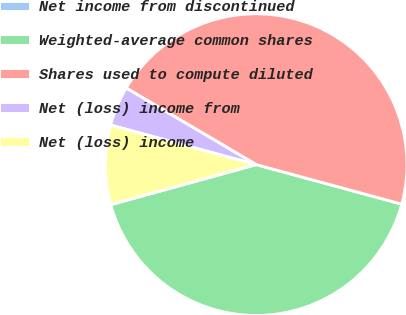Convert chart to OTSL. <chart><loc_0><loc_0><loc_500><loc_500><pie_chart><fcel>Net income from discontinued<fcel>Weighted-average common shares<fcel>Shares used to compute diluted<fcel>Net (loss) income from<fcel>Net (loss) income<nl><fcel>0.0%<fcel>41.5%<fcel>45.75%<fcel>4.25%<fcel>8.5%<nl></chart> 